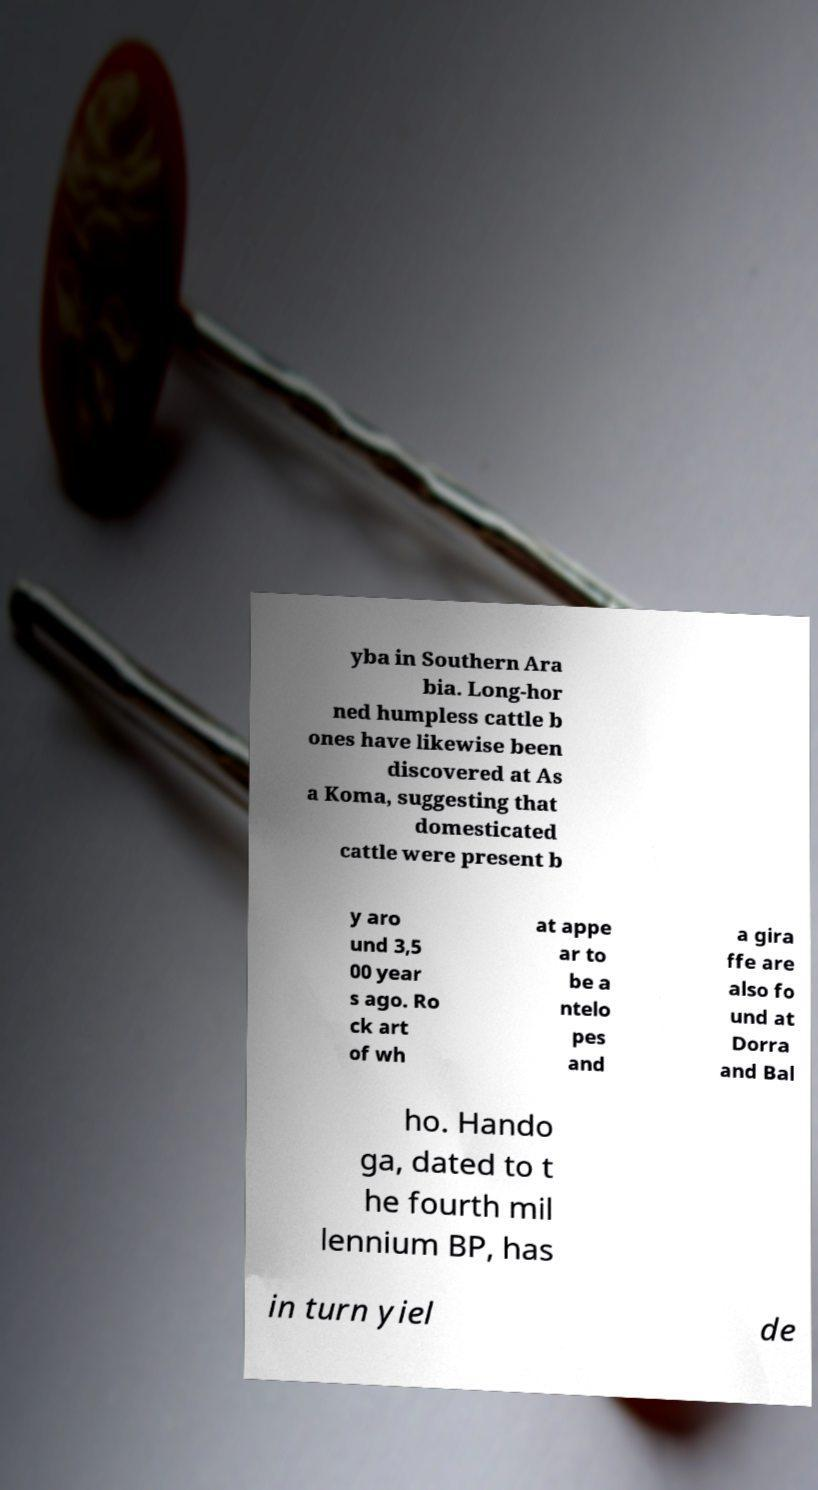Could you extract and type out the text from this image? yba in Southern Ara bia. Long-hor ned humpless cattle b ones have likewise been discovered at As a Koma, suggesting that domesticated cattle were present b y aro und 3,5 00 year s ago. Ro ck art of wh at appe ar to be a ntelo pes and a gira ffe are also fo und at Dorra and Bal ho. Hando ga, dated to t he fourth mil lennium BP, has in turn yiel de 